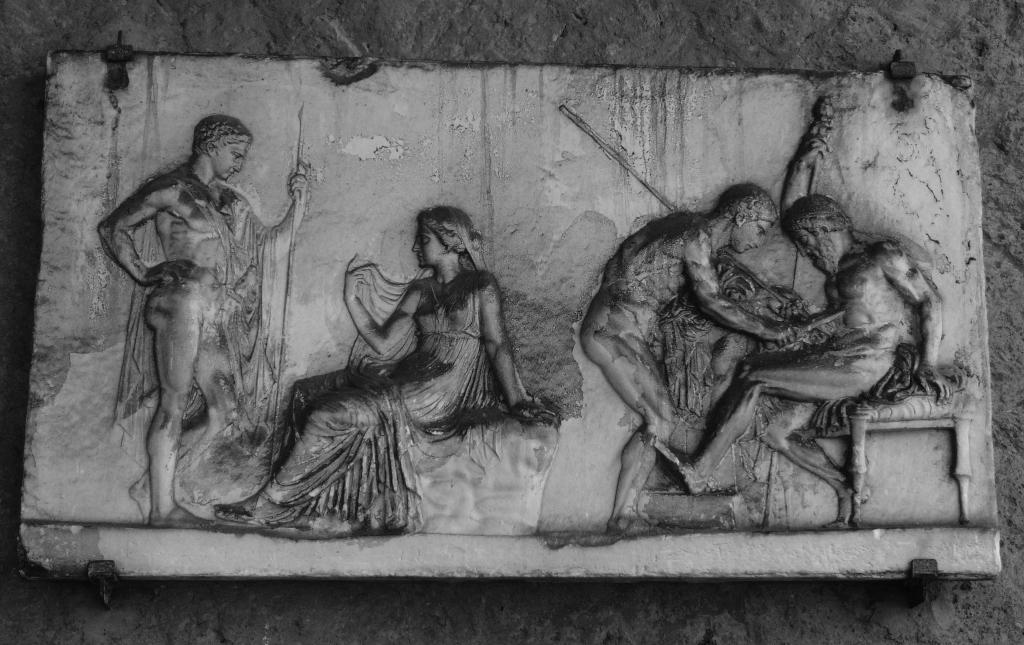Describe this image in one or two sentences. In the image there is a carving of few persons on a wall, this is a black and white picture. 